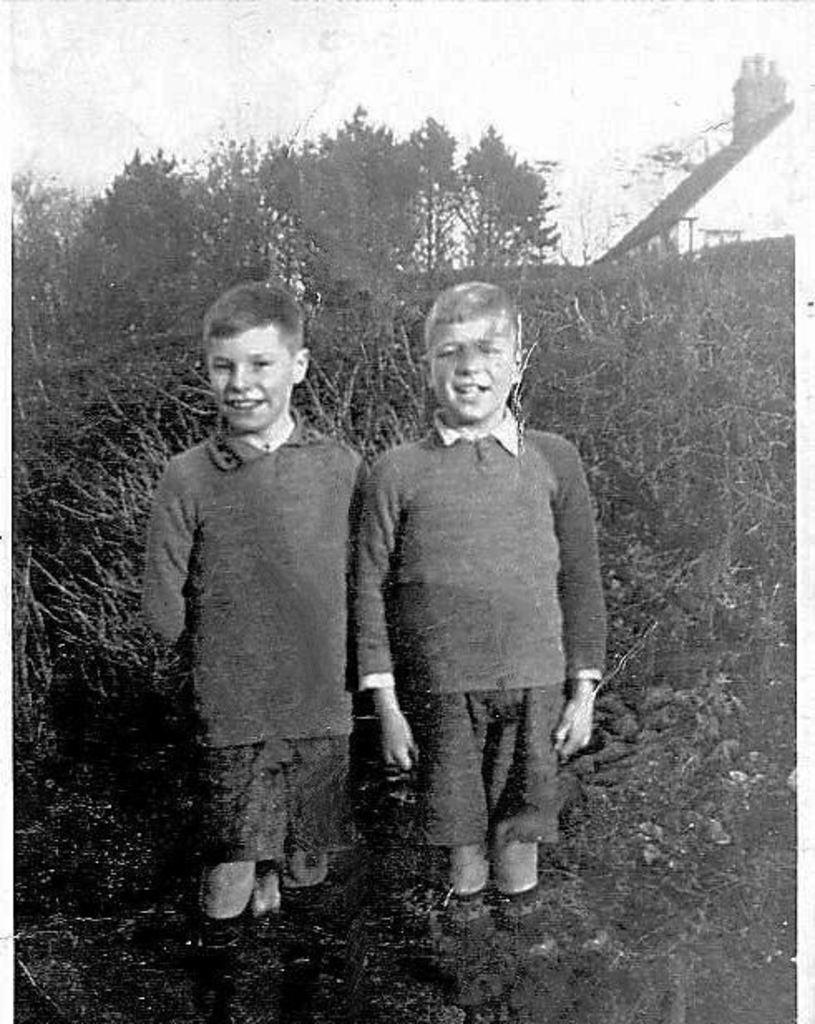How many boys are in the image? There are two boys standing in the image. What is the surface the boys are standing on? The boys are standing on land. What can be seen in the background of the image? Plants, trees, and the sky are visible in the background of the image. What is the color scheme of the image? The image is black and white. What type of thread is being used by the farmer in the image? There is no farmer or thread present in the image; it features two boys standing on land with a background of plants, trees, and the sky. 